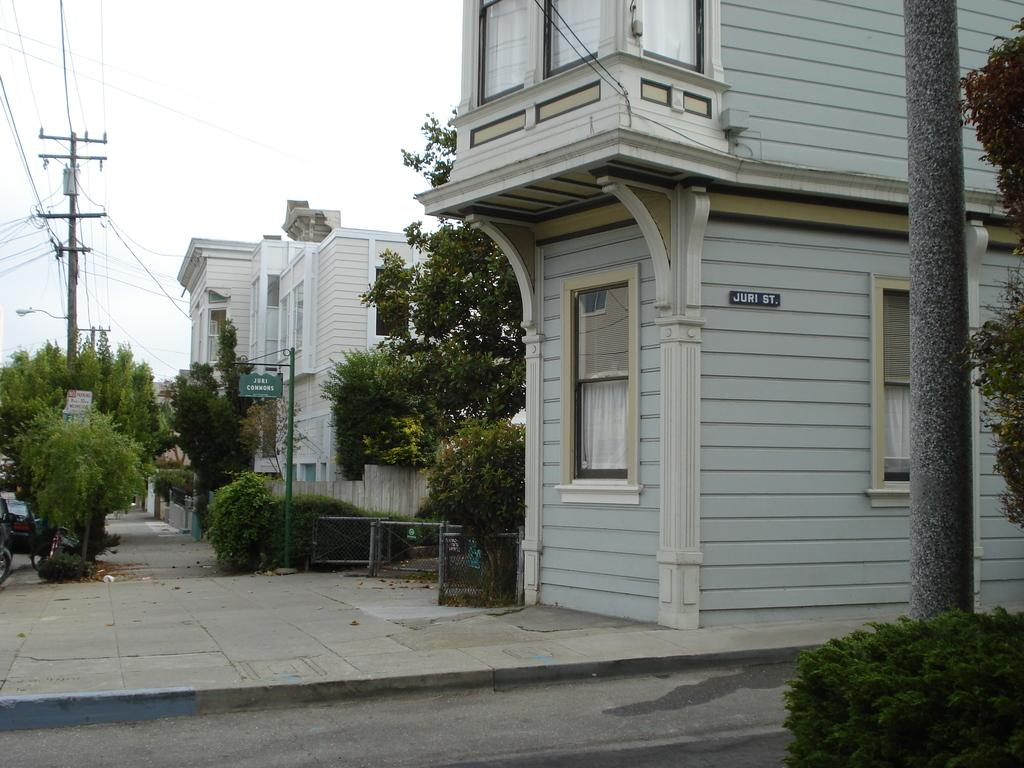What types of vegetation can be seen in the image? There are plants and trees in the image. What structures are present in the image? There are boards, poles, a mesh, and buildings in the image. What is the purpose of the poles in the image? The poles are likely used to support wires or other structures. What is the main feature of the road in the image? The road appears to be a paved surface for vehicles or pedestrians. What can be seen in the background of the image? The sky is visible in the background of the image. How many loaves of bread are being held by the plants in the image? There are no loaves of bread present in the image; it features plants, trees, boards, poles, a mesh, buildings, a road, and the sky. How many feet are visible on the buildings in the image? There is no indication of feet on the buildings in the image; it is a photograph of a scene with various structures and vegetation. 